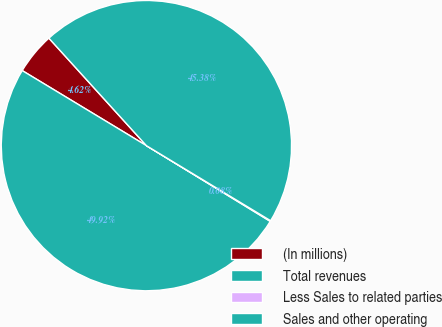Convert chart. <chart><loc_0><loc_0><loc_500><loc_500><pie_chart><fcel>(In millions)<fcel>Total revenues<fcel>Less Sales to related parties<fcel>Sales and other operating<nl><fcel>4.62%<fcel>49.92%<fcel>0.08%<fcel>45.38%<nl></chart> 